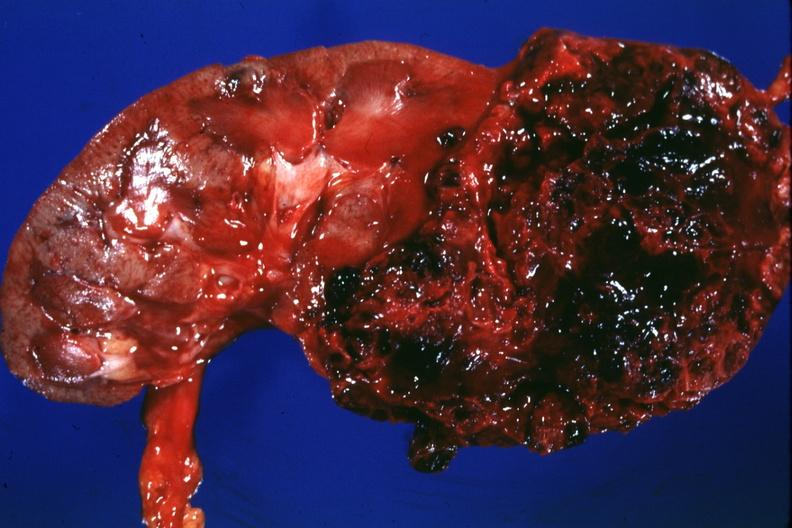what is present?
Answer the question using a single word or phrase. Kidney 